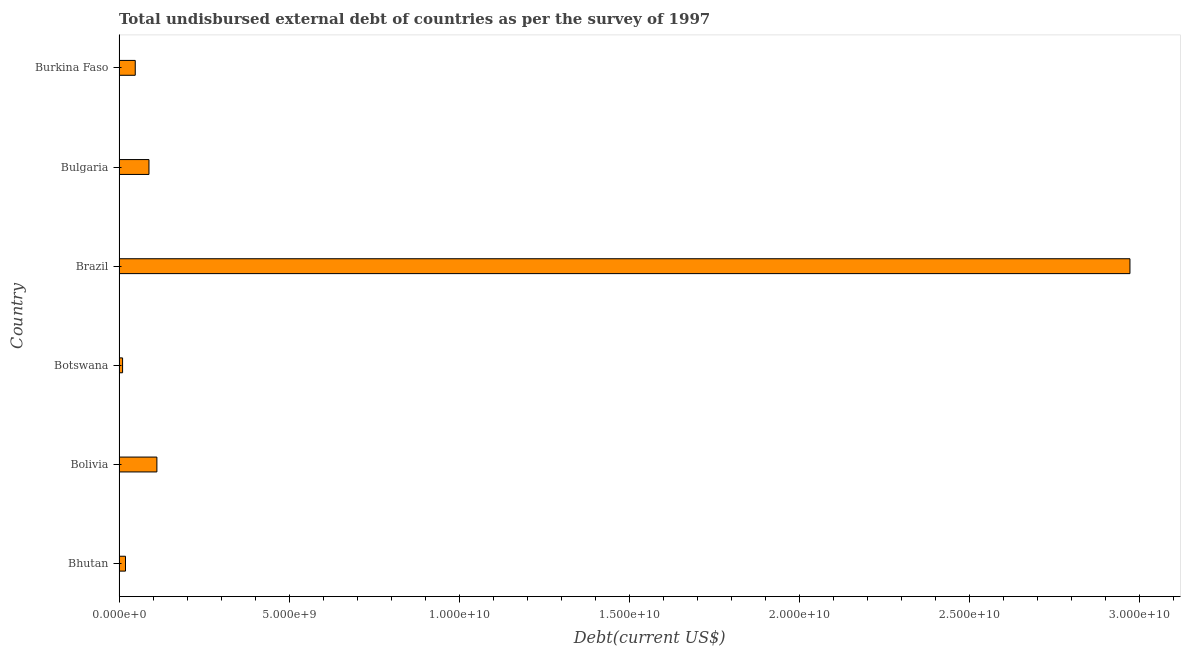What is the title of the graph?
Keep it short and to the point. Total undisbursed external debt of countries as per the survey of 1997. What is the label or title of the X-axis?
Offer a very short reply. Debt(current US$). What is the total debt in Brazil?
Provide a short and direct response. 2.97e+1. Across all countries, what is the maximum total debt?
Ensure brevity in your answer.  2.97e+1. Across all countries, what is the minimum total debt?
Provide a succinct answer. 1.03e+08. In which country was the total debt minimum?
Make the answer very short. Botswana. What is the sum of the total debt?
Your answer should be compact. 3.25e+1. What is the difference between the total debt in Bhutan and Burkina Faso?
Provide a short and direct response. -2.86e+08. What is the average total debt per country?
Offer a very short reply. 5.41e+09. What is the median total debt?
Offer a terse response. 6.78e+08. What is the ratio of the total debt in Bhutan to that in Bolivia?
Your answer should be very brief. 0.17. Is the total debt in Bolivia less than that in Bulgaria?
Keep it short and to the point. No. Is the difference between the total debt in Bulgaria and Burkina Faso greater than the difference between any two countries?
Keep it short and to the point. No. What is the difference between the highest and the second highest total debt?
Your answer should be compact. 2.86e+1. What is the difference between the highest and the lowest total debt?
Ensure brevity in your answer.  2.96e+1. How many bars are there?
Provide a succinct answer. 6. What is the difference between two consecutive major ticks on the X-axis?
Ensure brevity in your answer.  5.00e+09. What is the Debt(current US$) of Bhutan?
Keep it short and to the point. 1.90e+08. What is the Debt(current US$) in Bolivia?
Provide a short and direct response. 1.11e+09. What is the Debt(current US$) of Botswana?
Offer a very short reply. 1.03e+08. What is the Debt(current US$) of Brazil?
Your answer should be very brief. 2.97e+1. What is the Debt(current US$) of Bulgaria?
Your answer should be very brief. 8.80e+08. What is the Debt(current US$) of Burkina Faso?
Your answer should be very brief. 4.76e+08. What is the difference between the Debt(current US$) in Bhutan and Bolivia?
Make the answer very short. -9.23e+08. What is the difference between the Debt(current US$) in Bhutan and Botswana?
Your answer should be compact. 8.63e+07. What is the difference between the Debt(current US$) in Bhutan and Brazil?
Your response must be concise. -2.95e+1. What is the difference between the Debt(current US$) in Bhutan and Bulgaria?
Provide a succinct answer. -6.90e+08. What is the difference between the Debt(current US$) in Bhutan and Burkina Faso?
Your answer should be compact. -2.86e+08. What is the difference between the Debt(current US$) in Bolivia and Botswana?
Your answer should be very brief. 1.01e+09. What is the difference between the Debt(current US$) in Bolivia and Brazil?
Offer a terse response. -2.86e+1. What is the difference between the Debt(current US$) in Bolivia and Bulgaria?
Your answer should be very brief. 2.33e+08. What is the difference between the Debt(current US$) in Bolivia and Burkina Faso?
Your answer should be compact. 6.37e+08. What is the difference between the Debt(current US$) in Botswana and Brazil?
Keep it short and to the point. -2.96e+1. What is the difference between the Debt(current US$) in Botswana and Bulgaria?
Offer a very short reply. -7.76e+08. What is the difference between the Debt(current US$) in Botswana and Burkina Faso?
Your response must be concise. -3.73e+08. What is the difference between the Debt(current US$) in Brazil and Bulgaria?
Your response must be concise. 2.88e+1. What is the difference between the Debt(current US$) in Brazil and Burkina Faso?
Keep it short and to the point. 2.92e+1. What is the difference between the Debt(current US$) in Bulgaria and Burkina Faso?
Give a very brief answer. 4.04e+08. What is the ratio of the Debt(current US$) in Bhutan to that in Bolivia?
Your response must be concise. 0.17. What is the ratio of the Debt(current US$) in Bhutan to that in Botswana?
Offer a very short reply. 1.83. What is the ratio of the Debt(current US$) in Bhutan to that in Brazil?
Give a very brief answer. 0.01. What is the ratio of the Debt(current US$) in Bhutan to that in Bulgaria?
Provide a succinct answer. 0.22. What is the ratio of the Debt(current US$) in Bhutan to that in Burkina Faso?
Make the answer very short. 0.4. What is the ratio of the Debt(current US$) in Bolivia to that in Botswana?
Your answer should be compact. 10.76. What is the ratio of the Debt(current US$) in Bolivia to that in Brazil?
Make the answer very short. 0.04. What is the ratio of the Debt(current US$) in Bolivia to that in Bulgaria?
Give a very brief answer. 1.26. What is the ratio of the Debt(current US$) in Bolivia to that in Burkina Faso?
Your answer should be compact. 2.34. What is the ratio of the Debt(current US$) in Botswana to that in Brazil?
Ensure brevity in your answer.  0. What is the ratio of the Debt(current US$) in Botswana to that in Bulgaria?
Your answer should be very brief. 0.12. What is the ratio of the Debt(current US$) in Botswana to that in Burkina Faso?
Ensure brevity in your answer.  0.22. What is the ratio of the Debt(current US$) in Brazil to that in Bulgaria?
Provide a succinct answer. 33.79. What is the ratio of the Debt(current US$) in Brazil to that in Burkina Faso?
Give a very brief answer. 62.43. What is the ratio of the Debt(current US$) in Bulgaria to that in Burkina Faso?
Provide a short and direct response. 1.85. 